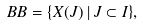Convert formula to latex. <formula><loc_0><loc_0><loc_500><loc_500>\ B B = \{ X ( J ) \, | \, J \subset I \} ,</formula> 